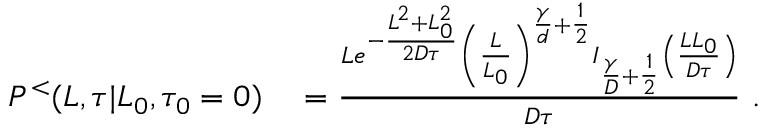Convert formula to latex. <formula><loc_0><loc_0><loc_500><loc_500>\begin{array} { r l } { P ^ { < } ( L , \tau | L _ { 0 } , \tau _ { 0 } = 0 ) } & = \frac { L e ^ { - \frac { L ^ { 2 } + L _ { 0 } ^ { 2 } } { 2 D \tau } } \left ( \frac { L } { L _ { 0 } } \right ) ^ { \frac { \gamma } { d } + \frac { 1 } { 2 } } I _ { \frac { \gamma } { D } + \frac { 1 } { 2 } } \left ( \frac { L L _ { 0 } } { D \tau } \right ) } { D \tau } \ . } \end{array}</formula> 